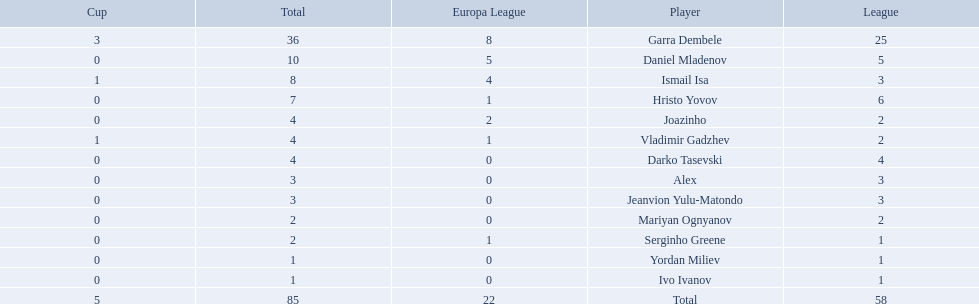What players did not score in all 3 competitions? Daniel Mladenov, Hristo Yovov, Joazinho, Darko Tasevski, Alex, Jeanvion Yulu-Matondo, Mariyan Ognyanov, Serginho Greene, Yordan Miliev, Ivo Ivanov. Which of those did not have total more then 5? Darko Tasevski, Alex, Jeanvion Yulu-Matondo, Mariyan Ognyanov, Serginho Greene, Yordan Miliev, Ivo Ivanov. Which ones scored more then 1 total? Darko Tasevski, Alex, Jeanvion Yulu-Matondo, Mariyan Ognyanov. Which of these player had the lease league points? Mariyan Ognyanov. 